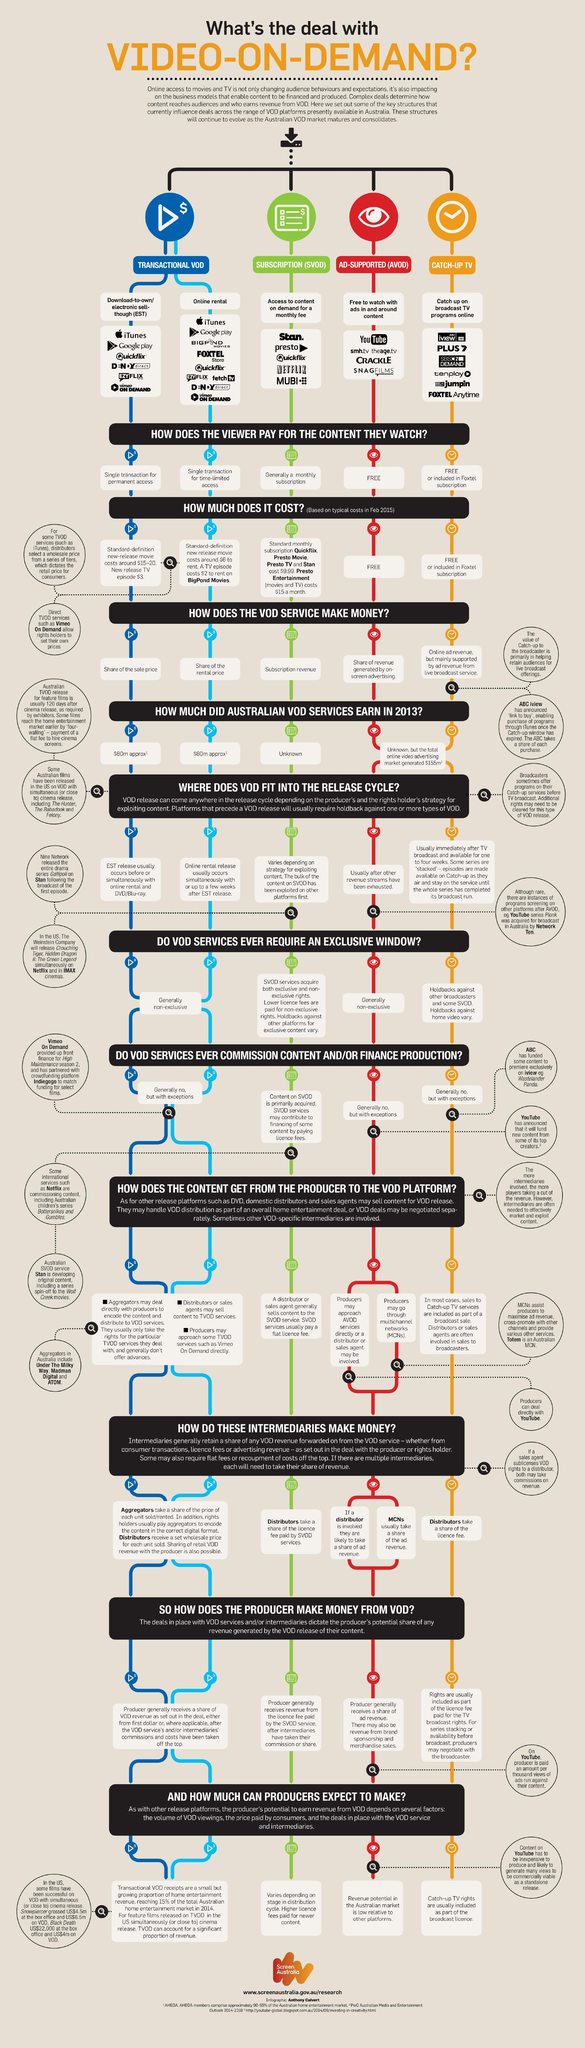What is the color code given to Subscription (SVOD)- blue, red, green, orange?
Answer the question with a short phrase. green How does YouTube earn cash? share of the revenue generated by on-screen advertising Which is the fourth type of Video on demand listed in the infographic? Catch-Up Tv How many different types of Transactional VOD is present? 2 How does Netflix earn cash? subscription revenue Which VOD is free to watch? AD-SUPPORTED (AVOD) How many VOD services are normally non-exclusive? 3 FOXTEL store, Google Play, iTunes is an example which kind of VOD? Transactional VOD Which are the initial three types of Video-on-demand mentioned in the infographic? Transactional VOD, Subscription (SVOD), Ad-Supported (AVOD) YouTube is an example which kind of VOD? AD-SUPPORTED (AVOD) 